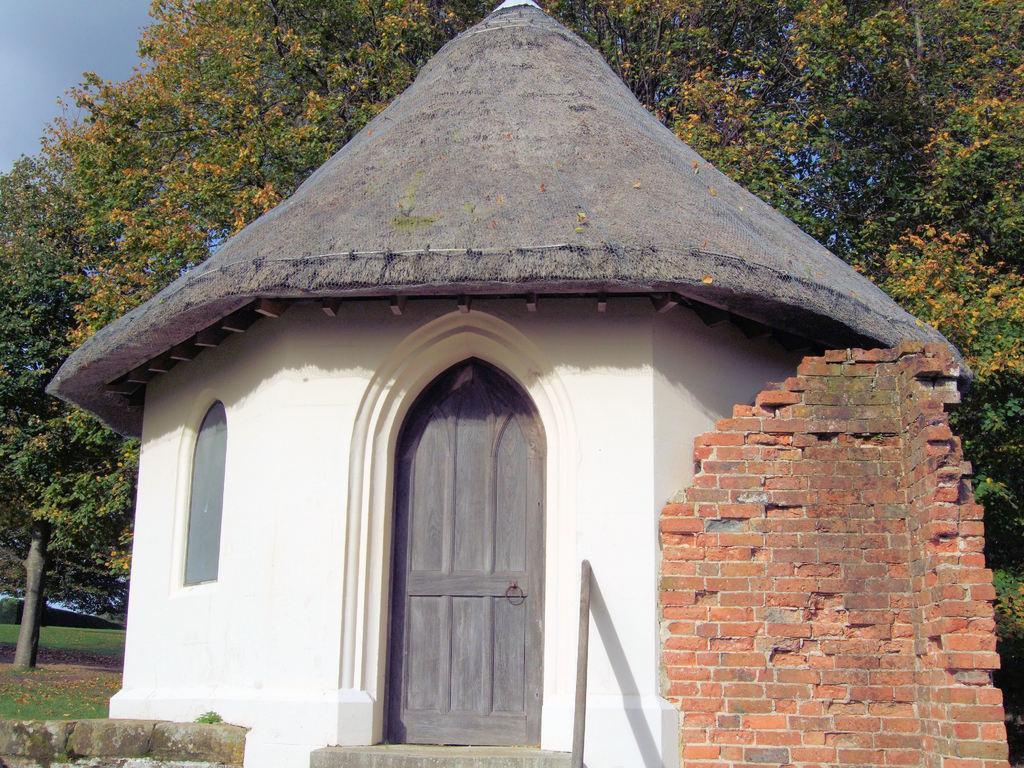Please provide a concise description of this image. This picture is clicked outside. On the right we can see the brick wall. In the center we can see the hutt and some other items. In the background we can see the sky, trees, green grass and some other objects. 